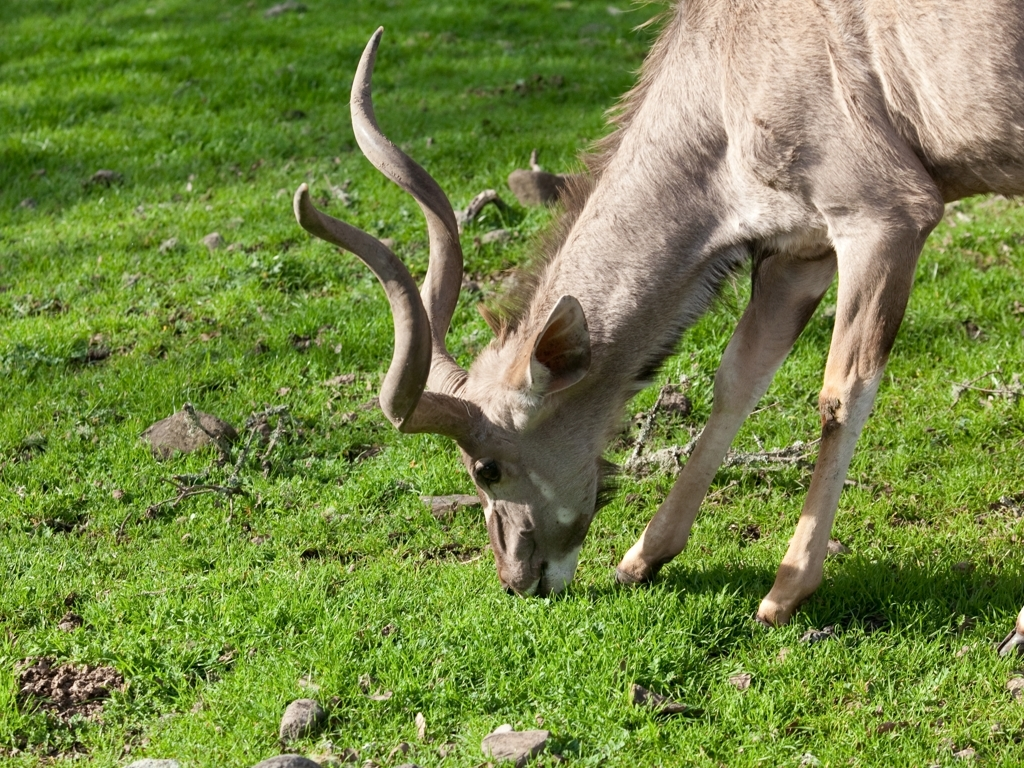Describe the current weather conditions and how they might affect the deer. The image presents a sunny and seemingly warm environment without evident signs of recent rainfall. These favorable conditions typically promote abundant food resources and may result in increased periods of foraging activity for the deer. 